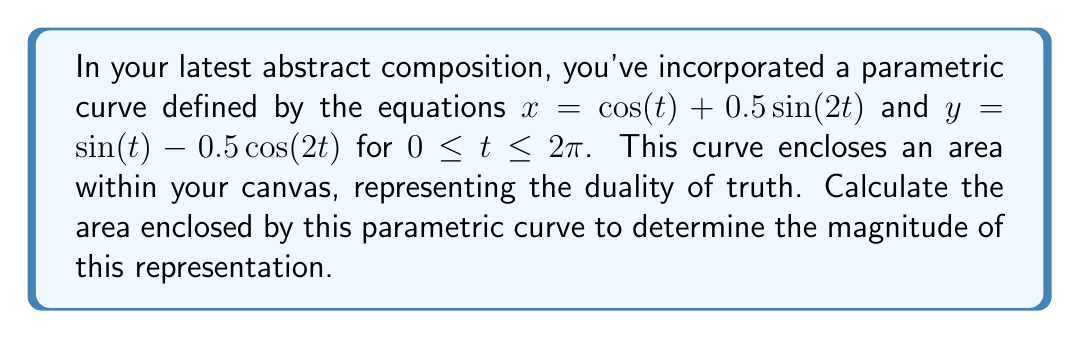Teach me how to tackle this problem. To calculate the area enclosed by a parametric curve, we can use the formula:

$$A = \frac{1}{2} \int_a^b [x(t)\frac{dy}{dt} - y(t)\frac{dx}{dt}] dt$$

Where $a$ and $b$ are the start and end values of the parameter $t$.

Step 1: Calculate $\frac{dx}{dt}$ and $\frac{dy}{dt}$
$$\frac{dx}{dt} = -\sin(t) + \cos(2t)$$
$$\frac{dy}{dt} = \cos(t) + \sin(2t)$$

Step 2: Substitute these values into the area formula
$$A = \frac{1}{2} \int_0^{2\pi} [(\cos(t) + 0.5\sin(2t))(\cos(t) + \sin(2t)) - (\sin(t) - 0.5\cos(2t))(-\sin(t) + \cos(2t))] dt$$

Step 3: Expand the expression inside the integral
$$A = \frac{1}{2} \int_0^{2\pi} [\cos^2(t) + \cos(t)\sin(2t) + 0.5\sin(2t)\cos(t) + 0.5\sin^2(2t) + \sin^2(t) - \sin(t)\cos(2t) + 0.5\cos(2t)\sin(t) - 0.5\cos^2(2t)] dt$$

Step 4: Simplify using trigonometric identities
$$A = \frac{1}{2} \int_0^{2\pi} [1 + 1.5\cos(t)\sin(2t) - 0.5\sin(t)\cos(2t) + 0.5\sin^2(2t) - 0.5\cos^2(2t)] dt$$
$$A = \frac{1}{2} \int_0^{2\pi} [1 + 1.5\cos(t)\sin(2t) - 0.5\sin(t)\cos(2t) - 0.5\cos(4t)] dt$$

Step 5: Integrate term by term
- $\int_0^{2\pi} 1 dt = 2\pi$
- $\int_0^{2\pi} \cos(t)\sin(2t) dt = 0$
- $\int_0^{2\pi} \sin(t)\cos(2t) dt = 0$
- $\int_0^{2\pi} \cos(4t) dt = 0$

Step 6: Calculate the final result
$$A = \frac{1}{2} (2\pi) = \pi$$
Answer: The area enclosed by the parametric curve is $\pi$ square units. 